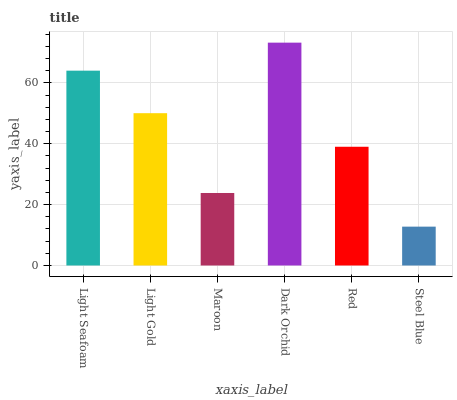Is Steel Blue the minimum?
Answer yes or no. Yes. Is Dark Orchid the maximum?
Answer yes or no. Yes. Is Light Gold the minimum?
Answer yes or no. No. Is Light Gold the maximum?
Answer yes or no. No. Is Light Seafoam greater than Light Gold?
Answer yes or no. Yes. Is Light Gold less than Light Seafoam?
Answer yes or no. Yes. Is Light Gold greater than Light Seafoam?
Answer yes or no. No. Is Light Seafoam less than Light Gold?
Answer yes or no. No. Is Light Gold the high median?
Answer yes or no. Yes. Is Red the low median?
Answer yes or no. Yes. Is Dark Orchid the high median?
Answer yes or no. No. Is Steel Blue the low median?
Answer yes or no. No. 